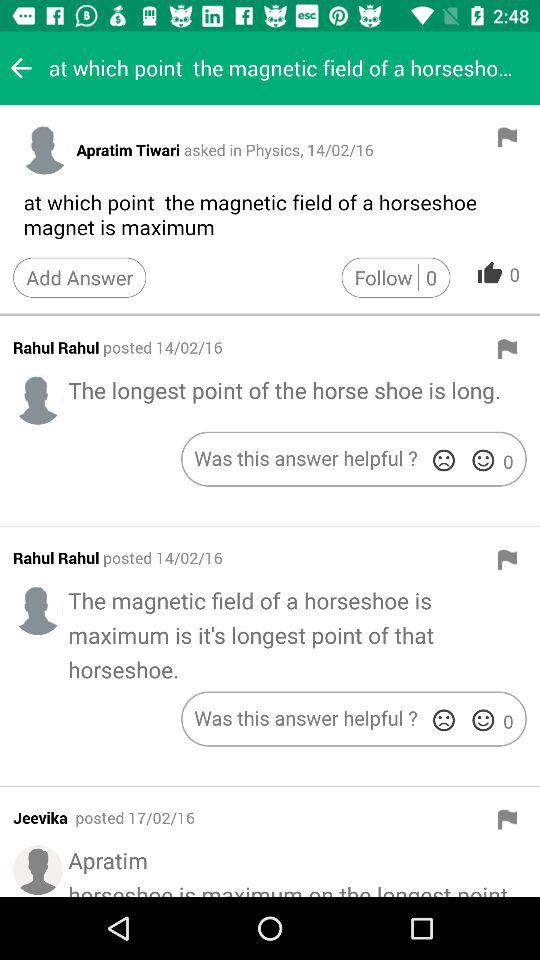How many followers are there? There are 0 followers. 